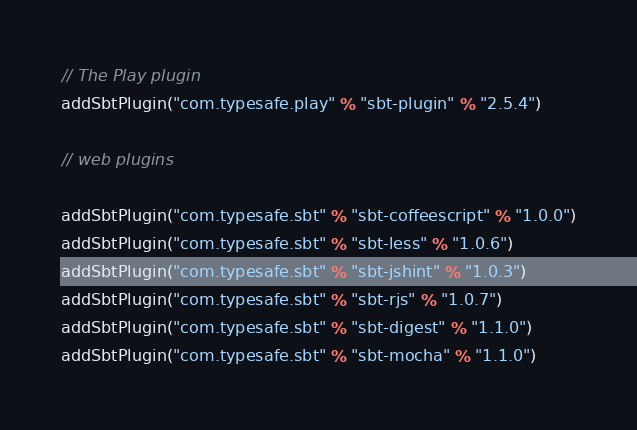Convert code to text. <code><loc_0><loc_0><loc_500><loc_500><_Scala_>// The Play plugin
addSbtPlugin("com.typesafe.play" % "sbt-plugin" % "2.5.4")

// web plugins

addSbtPlugin("com.typesafe.sbt" % "sbt-coffeescript" % "1.0.0")
addSbtPlugin("com.typesafe.sbt" % "sbt-less" % "1.0.6")
addSbtPlugin("com.typesafe.sbt" % "sbt-jshint" % "1.0.3")
addSbtPlugin("com.typesafe.sbt" % "sbt-rjs" % "1.0.7")
addSbtPlugin("com.typesafe.sbt" % "sbt-digest" % "1.1.0")
addSbtPlugin("com.typesafe.sbt" % "sbt-mocha" % "1.1.0")
</code> 